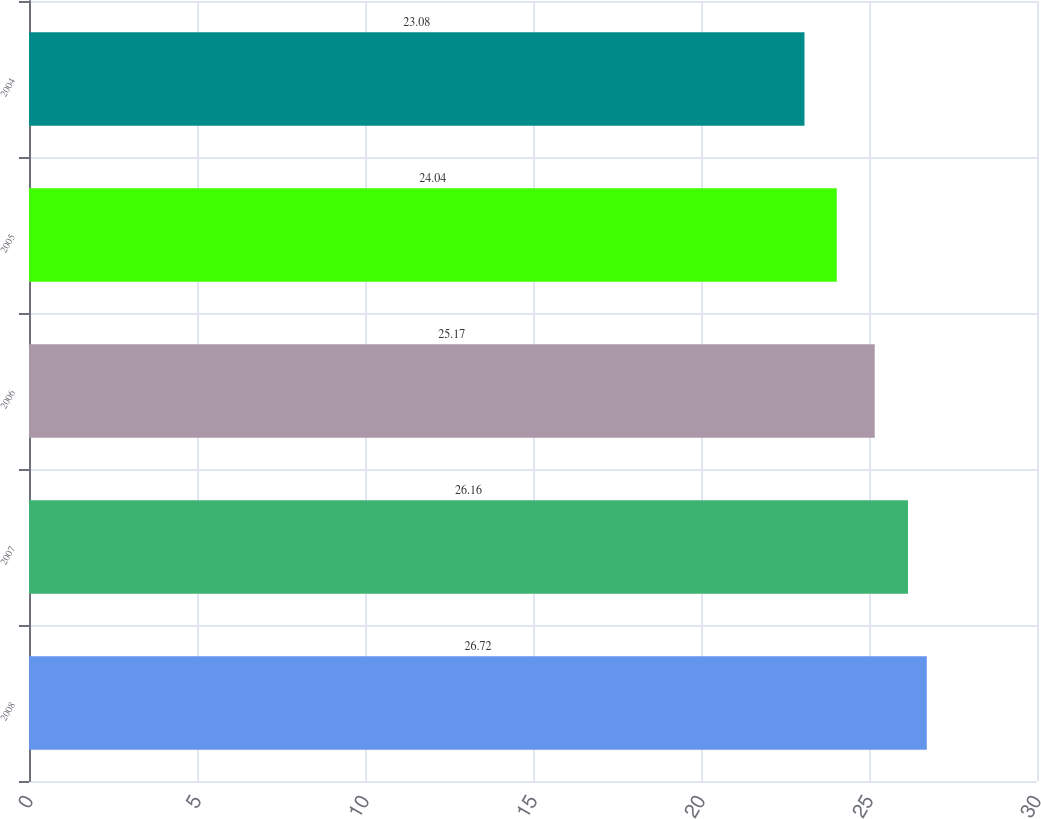<chart> <loc_0><loc_0><loc_500><loc_500><bar_chart><fcel>2008<fcel>2007<fcel>2006<fcel>2005<fcel>2004<nl><fcel>26.72<fcel>26.16<fcel>25.17<fcel>24.04<fcel>23.08<nl></chart> 